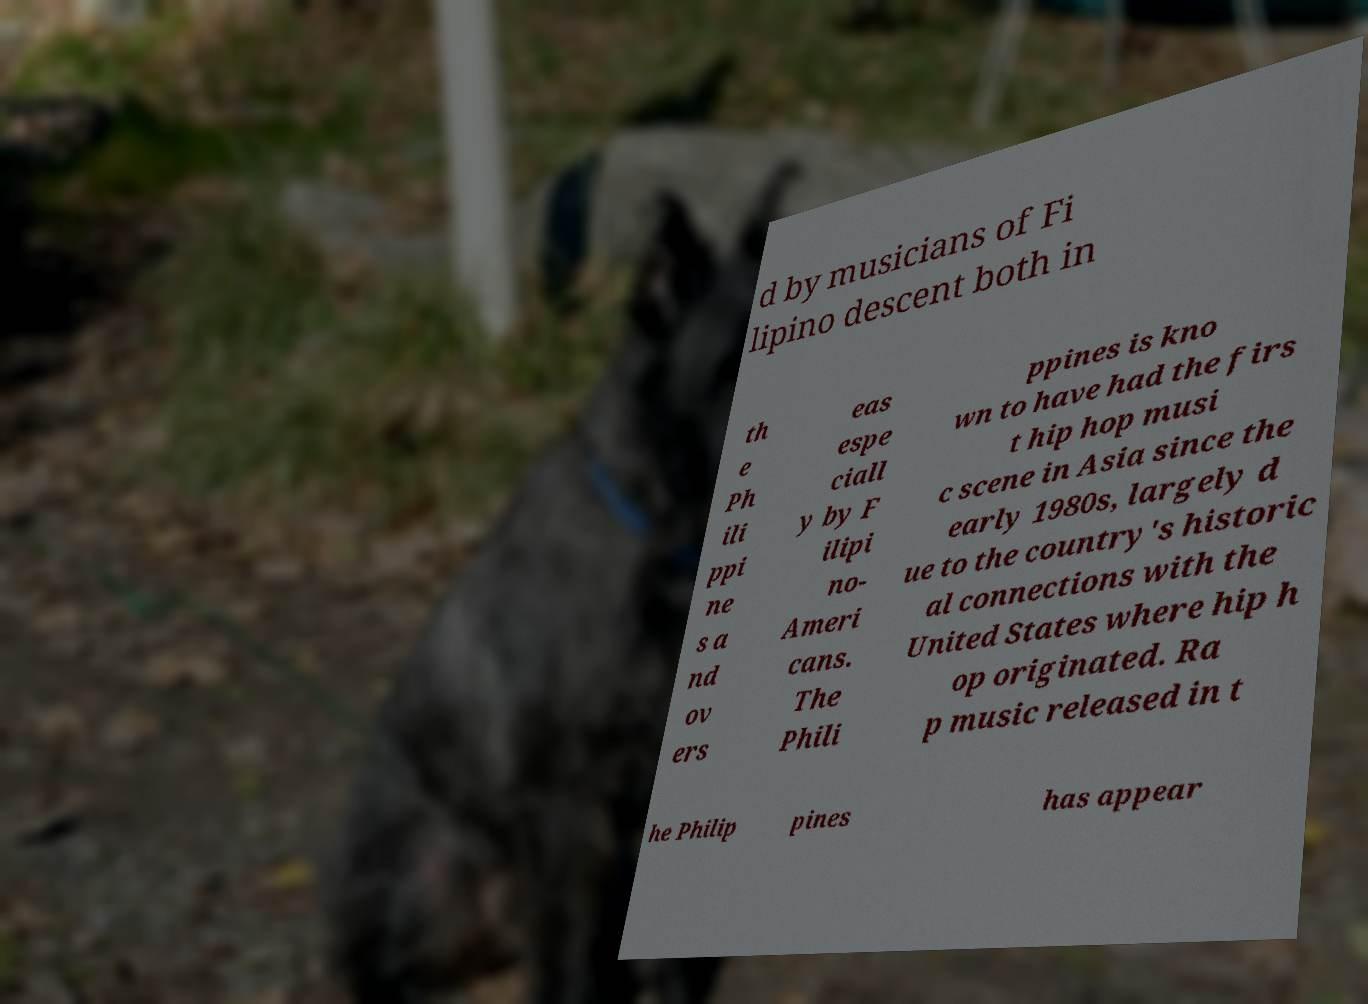There's text embedded in this image that I need extracted. Can you transcribe it verbatim? d by musicians of Fi lipino descent both in th e Ph ili ppi ne s a nd ov ers eas espe ciall y by F ilipi no- Ameri cans. The Phili ppines is kno wn to have had the firs t hip hop musi c scene in Asia since the early 1980s, largely d ue to the country's historic al connections with the United States where hip h op originated. Ra p music released in t he Philip pines has appear 